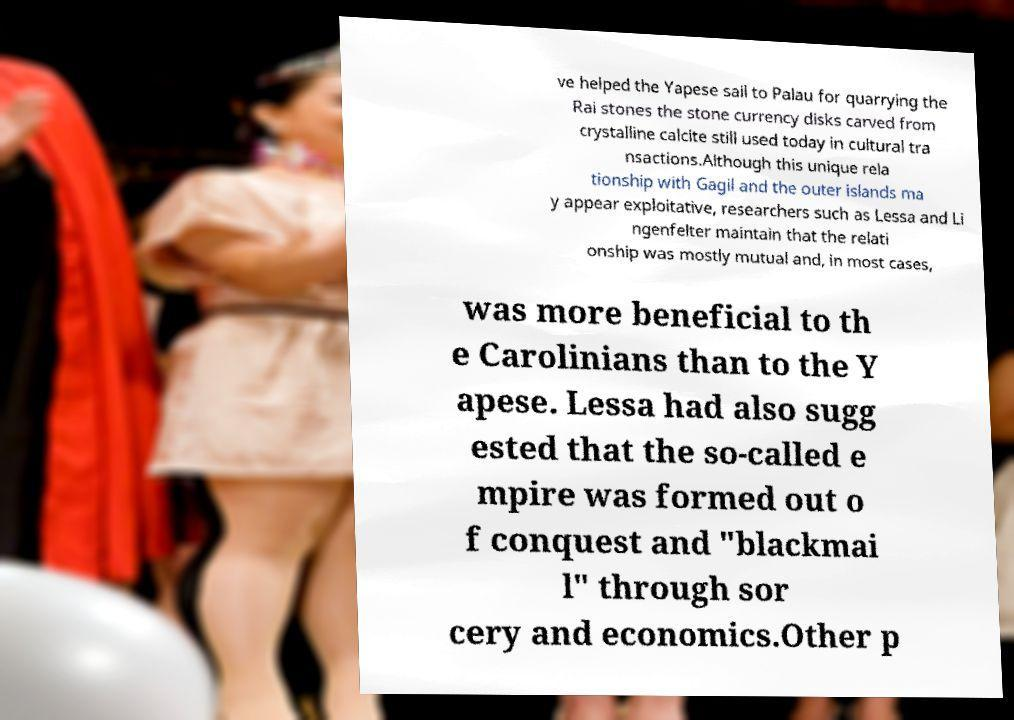Can you accurately transcribe the text from the provided image for me? ve helped the Yapese sail to Palau for quarrying the Rai stones the stone currency disks carved from crystalline calcite still used today in cultural tra nsactions.Although this unique rela tionship with Gagil and the outer islands ma y appear exploitative, researchers such as Lessa and Li ngenfelter maintain that the relati onship was mostly mutual and, in most cases, was more beneficial to th e Carolinians than to the Y apese. Lessa had also sugg ested that the so-called e mpire was formed out o f conquest and "blackmai l" through sor cery and economics.Other p 